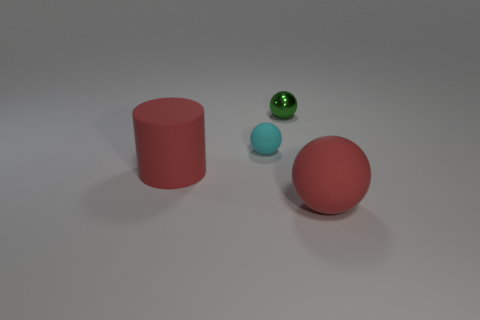Subtract all small cyan spheres. How many spheres are left? 2 Subtract all spheres. How many objects are left? 1 Add 3 large red matte cubes. How many objects exist? 7 Add 1 tiny metal spheres. How many tiny metal spheres exist? 2 Subtract all red spheres. How many spheres are left? 2 Subtract 0 cyan blocks. How many objects are left? 4 Subtract 1 spheres. How many spheres are left? 2 Subtract all purple cylinders. Subtract all red cubes. How many cylinders are left? 1 Subtract all green cylinders. How many red balls are left? 1 Subtract all gray balls. Subtract all tiny matte balls. How many objects are left? 3 